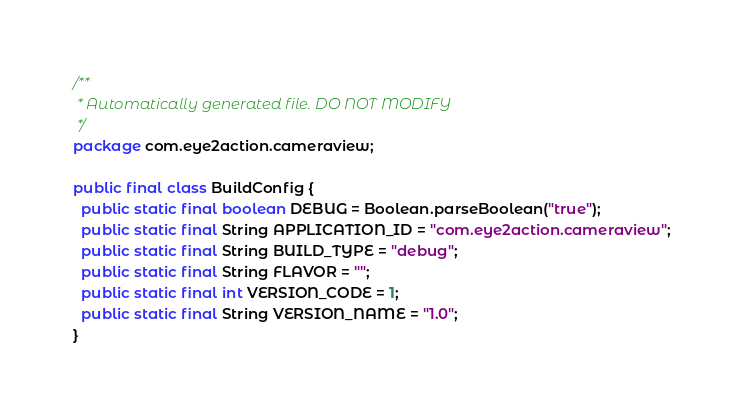Convert code to text. <code><loc_0><loc_0><loc_500><loc_500><_Java_>/**
 * Automatically generated file. DO NOT MODIFY
 */
package com.eye2action.cameraview;

public final class BuildConfig {
  public static final boolean DEBUG = Boolean.parseBoolean("true");
  public static final String APPLICATION_ID = "com.eye2action.cameraview";
  public static final String BUILD_TYPE = "debug";
  public static final String FLAVOR = "";
  public static final int VERSION_CODE = 1;
  public static final String VERSION_NAME = "1.0";
}
</code> 